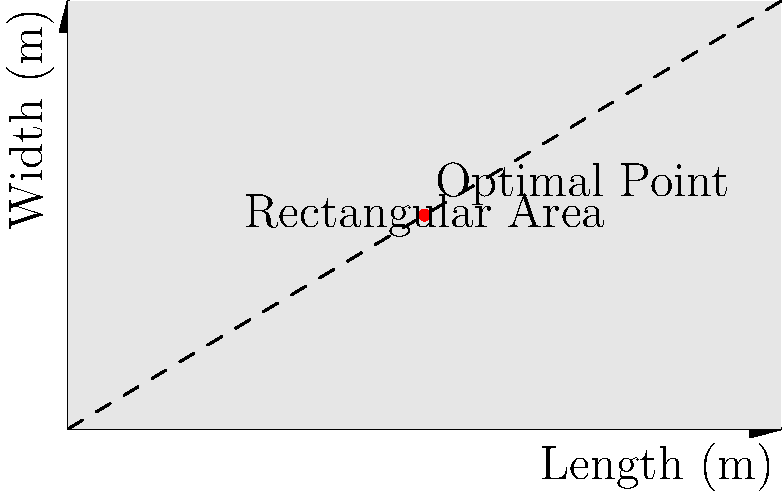A temporary refugee shelter needs to be constructed within a rectangular area of 60 square meters. The cost of materials for the walls is $20 per meter, while the cost for the roof is $30 per square meter. Using calculus of variations, determine the optimal dimensions (length and width) of the shelter that will minimize the total cost of construction. Assume the shelter has a flat roof and vertical walls. Let's approach this step-by-step:

1) Let $x$ be the length and $y$ be the width of the shelter.

2) Given that the area is 60 square meters, we have:
   $xy = 60$

3) The cost function $C$ consists of two parts:
   - Wall cost: $20 \cdot 2(x+y)$ (perimeter multiplied by cost per meter)
   - Roof cost: $30 \cdot xy$ (area multiplied by cost per square meter)

   $C = 20 \cdot 2(x+y) + 30xy$

4) Substituting $y = 60/x$ from step 2:
   $C = 40(x + 60/x) + 1800/x$

5) To minimize $C$, we differentiate with respect to $x$ and set it to zero:
   $\frac{dC}{dx} = 40 - 2400/x^2 + (-1800)/x^2 = 0$

6) Simplifying:
   $40 - 4200/x^2 = 0$
   $40x^2 = 4200$
   $x^2 = 105$
   $x = \sqrt{105} \approx 10.25$ meters

7) Since $xy = 60$, $y = 60/x = 60/\sqrt{105} \approx 5.86$ meters

8) Check the second derivative to confirm this is a minimum:
   $\frac{d^2C}{dx^2} = 8400/x^3 > 0$ for positive $x$, confirming a minimum.
Answer: Length: $\sqrt{105} \approx 10.25$ m, Width: $60/\sqrt{105} \approx 5.86$ m 